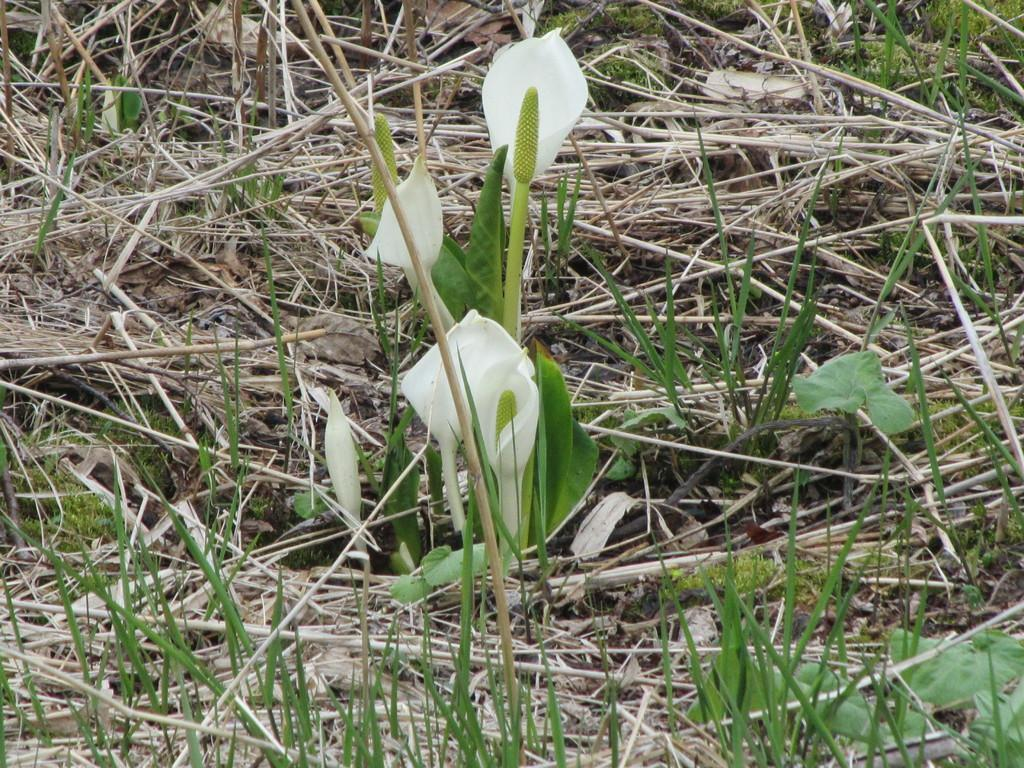What type of plants can be seen in the image? There are flowers in the image. What part of the flowers are visible? The flowers have stems. What type of vegetation is present in the image besides the flowers? There is dry grass visible in the image. What type of soup is being served in the image? There is no soup present in the image; it features flowers and dry grass. 